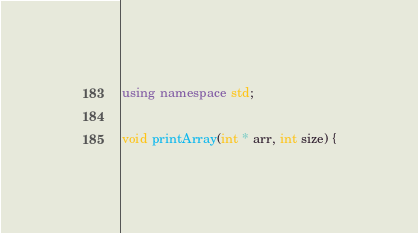<code> <loc_0><loc_0><loc_500><loc_500><_C++_>
using namespace std;

void printArray(int * arr, int size) {</code> 